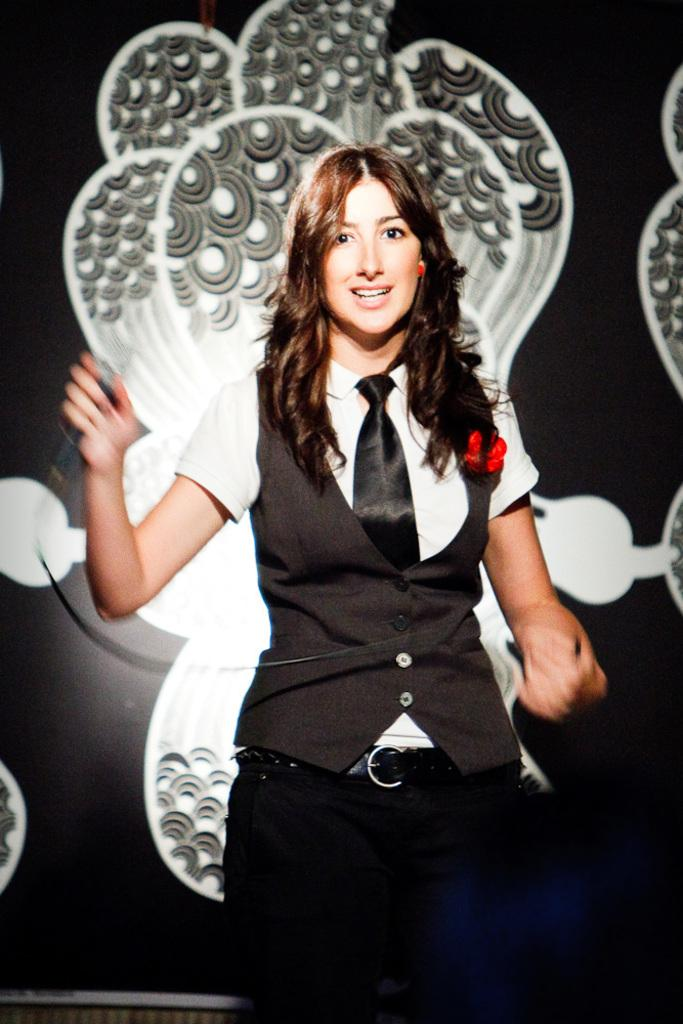Who is the main subject in the image? There is a woman in the center of the picture. What is the woman holding in the image? The woman is holding a mic. What can be seen in the background of the image? There is a well in the background of the image. Can you describe any patterns or designs in the image? Yes, there are designs on the wall in the image. What type of bread can be seen in the image? There is no bread present in the image. How many members are on the team in the image? There is no team present in the image. 